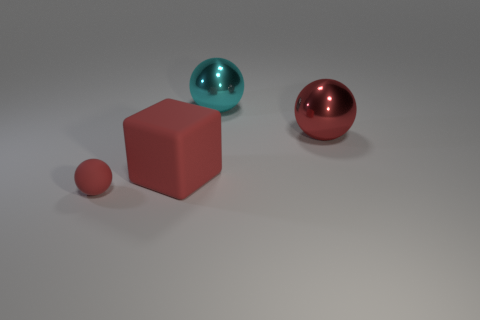Is there any other thing that is the same size as the rubber sphere?
Your response must be concise. No. There is a big block that is the same color as the tiny rubber thing; what material is it?
Make the answer very short. Rubber. What number of gray things are either spheres or tiny rubber objects?
Provide a short and direct response. 0. There is a rubber ball that is the same color as the large block; what is its size?
Your response must be concise. Small. Is the number of red balls greater than the number of big red blocks?
Offer a terse response. Yes. Does the large matte block have the same color as the tiny sphere?
Make the answer very short. Yes. What number of things are either large cyan things or red things that are on the right side of the tiny object?
Your response must be concise. 3. How many other things are there of the same shape as the cyan shiny object?
Make the answer very short. 2. Are there fewer cubes that are on the left side of the small red thing than red cubes on the left side of the large rubber object?
Your answer should be compact. No. What shape is the red object that is made of the same material as the large cube?
Give a very brief answer. Sphere. 